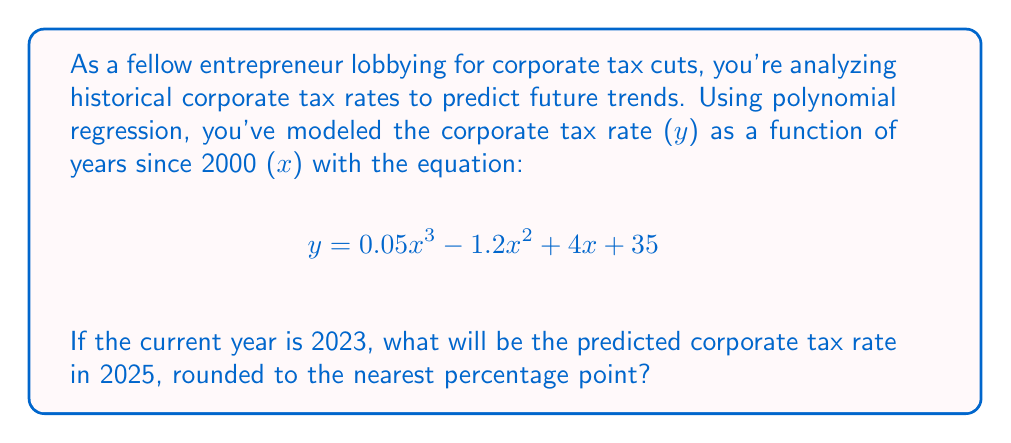Could you help me with this problem? Let's approach this step-by-step:

1) First, we need to determine the value of x for the year 2025:
   2025 - 2000 = 25 years

2) Now, we substitute x = 25 into our polynomial equation:

   $$y = 0.05(25)^3 - 1.2(25)^2 + 4(25) + 35$$

3) Let's calculate each term:
   
   $0.05(25)^3 = 0.05 * 15625 = 781.25$
   $-1.2(25)^2 = -1.2 * 625 = -750$
   $4(25) = 100$
   $35$ remains as is

4) Now we sum these terms:

   $$y = 781.25 - 750 + 100 + 35 = 166.25$$

5) Rounding to the nearest percentage point:

   166.25 rounds to 166%

Therefore, the predicted corporate tax rate for 2025 is 166%.
Answer: 166% 